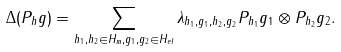Convert formula to latex. <formula><loc_0><loc_0><loc_500><loc_500>\Delta ( P _ { h } g ) = \sum _ { h _ { 1 } , h _ { 2 } \in H _ { m } , g _ { 1 } , g _ { 2 } \in H _ { e l } } \lambda _ { h _ { 1 } , g _ { 1 } , h _ { 2 } , g _ { 2 } } P _ { h _ { 1 } } g _ { 1 } \otimes P _ { h _ { 2 } } g _ { 2 } .</formula> 